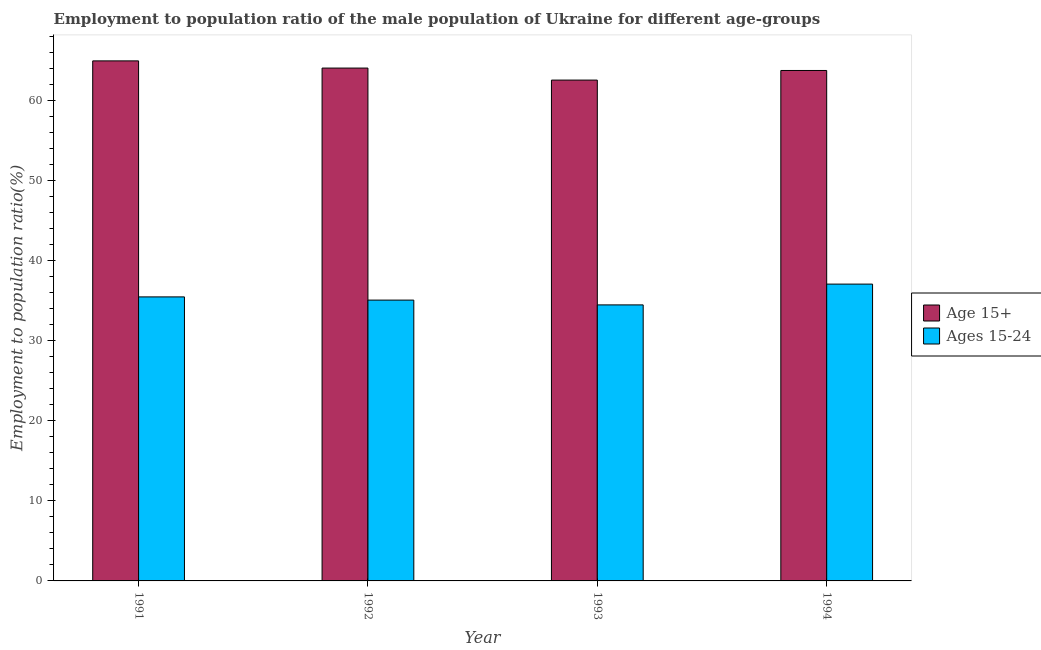How many groups of bars are there?
Your answer should be compact. 4. Are the number of bars on each tick of the X-axis equal?
Give a very brief answer. Yes. How many bars are there on the 4th tick from the right?
Provide a succinct answer. 2. In how many cases, is the number of bars for a given year not equal to the number of legend labels?
Give a very brief answer. 0. What is the employment to population ratio(age 15-24) in 1993?
Make the answer very short. 34.5. Across all years, what is the maximum employment to population ratio(age 15-24)?
Keep it short and to the point. 37.1. Across all years, what is the minimum employment to population ratio(age 15-24)?
Your answer should be very brief. 34.5. In which year was the employment to population ratio(age 15+) minimum?
Offer a very short reply. 1993. What is the total employment to population ratio(age 15-24) in the graph?
Offer a terse response. 142.2. What is the difference between the employment to population ratio(age 15+) in 1993 and that in 1994?
Offer a very short reply. -1.2. What is the difference between the employment to population ratio(age 15-24) in 1991 and the employment to population ratio(age 15+) in 1993?
Give a very brief answer. 1. What is the average employment to population ratio(age 15-24) per year?
Offer a very short reply. 35.55. What is the ratio of the employment to population ratio(age 15-24) in 1991 to that in 1994?
Make the answer very short. 0.96. Is the employment to population ratio(age 15+) in 1992 less than that in 1994?
Provide a short and direct response. No. Is the difference between the employment to population ratio(age 15+) in 1991 and 1993 greater than the difference between the employment to population ratio(age 15-24) in 1991 and 1993?
Offer a terse response. No. What is the difference between the highest and the second highest employment to population ratio(age 15-24)?
Make the answer very short. 1.6. What is the difference between the highest and the lowest employment to population ratio(age 15-24)?
Ensure brevity in your answer.  2.6. What does the 2nd bar from the left in 1991 represents?
Provide a succinct answer. Ages 15-24. What does the 2nd bar from the right in 1991 represents?
Keep it short and to the point. Age 15+. What is the difference between two consecutive major ticks on the Y-axis?
Your answer should be very brief. 10. Are the values on the major ticks of Y-axis written in scientific E-notation?
Make the answer very short. No. Does the graph contain grids?
Offer a very short reply. No. Where does the legend appear in the graph?
Provide a short and direct response. Center right. How many legend labels are there?
Provide a short and direct response. 2. What is the title of the graph?
Your response must be concise. Employment to population ratio of the male population of Ukraine for different age-groups. Does "Study and work" appear as one of the legend labels in the graph?
Provide a succinct answer. No. What is the label or title of the Y-axis?
Offer a terse response. Employment to population ratio(%). What is the Employment to population ratio(%) in Ages 15-24 in 1991?
Provide a succinct answer. 35.5. What is the Employment to population ratio(%) of Age 15+ in 1992?
Your answer should be very brief. 64.1. What is the Employment to population ratio(%) in Ages 15-24 in 1992?
Your answer should be very brief. 35.1. What is the Employment to population ratio(%) of Age 15+ in 1993?
Your answer should be very brief. 62.6. What is the Employment to population ratio(%) in Ages 15-24 in 1993?
Provide a short and direct response. 34.5. What is the Employment to population ratio(%) in Age 15+ in 1994?
Provide a short and direct response. 63.8. What is the Employment to population ratio(%) in Ages 15-24 in 1994?
Make the answer very short. 37.1. Across all years, what is the maximum Employment to population ratio(%) of Age 15+?
Your answer should be compact. 65. Across all years, what is the maximum Employment to population ratio(%) in Ages 15-24?
Give a very brief answer. 37.1. Across all years, what is the minimum Employment to population ratio(%) in Age 15+?
Give a very brief answer. 62.6. Across all years, what is the minimum Employment to population ratio(%) of Ages 15-24?
Keep it short and to the point. 34.5. What is the total Employment to population ratio(%) of Age 15+ in the graph?
Give a very brief answer. 255.5. What is the total Employment to population ratio(%) of Ages 15-24 in the graph?
Make the answer very short. 142.2. What is the difference between the Employment to population ratio(%) in Ages 15-24 in 1991 and that in 1992?
Provide a succinct answer. 0.4. What is the difference between the Employment to population ratio(%) of Age 15+ in 1991 and that in 1994?
Your answer should be compact. 1.2. What is the difference between the Employment to population ratio(%) of Age 15+ in 1992 and that in 1993?
Make the answer very short. 1.5. What is the difference between the Employment to population ratio(%) of Ages 15-24 in 1992 and that in 1993?
Offer a very short reply. 0.6. What is the difference between the Employment to population ratio(%) of Age 15+ in 1992 and that in 1994?
Offer a terse response. 0.3. What is the difference between the Employment to population ratio(%) in Age 15+ in 1993 and that in 1994?
Offer a terse response. -1.2. What is the difference between the Employment to population ratio(%) in Ages 15-24 in 1993 and that in 1994?
Offer a terse response. -2.6. What is the difference between the Employment to population ratio(%) of Age 15+ in 1991 and the Employment to population ratio(%) of Ages 15-24 in 1992?
Your answer should be very brief. 29.9. What is the difference between the Employment to population ratio(%) in Age 15+ in 1991 and the Employment to population ratio(%) in Ages 15-24 in 1993?
Give a very brief answer. 30.5. What is the difference between the Employment to population ratio(%) of Age 15+ in 1991 and the Employment to population ratio(%) of Ages 15-24 in 1994?
Offer a terse response. 27.9. What is the difference between the Employment to population ratio(%) in Age 15+ in 1992 and the Employment to population ratio(%) in Ages 15-24 in 1993?
Offer a terse response. 29.6. What is the difference between the Employment to population ratio(%) of Age 15+ in 1993 and the Employment to population ratio(%) of Ages 15-24 in 1994?
Ensure brevity in your answer.  25.5. What is the average Employment to population ratio(%) in Age 15+ per year?
Your response must be concise. 63.88. What is the average Employment to population ratio(%) in Ages 15-24 per year?
Make the answer very short. 35.55. In the year 1991, what is the difference between the Employment to population ratio(%) of Age 15+ and Employment to population ratio(%) of Ages 15-24?
Offer a very short reply. 29.5. In the year 1992, what is the difference between the Employment to population ratio(%) of Age 15+ and Employment to population ratio(%) of Ages 15-24?
Your answer should be compact. 29. In the year 1993, what is the difference between the Employment to population ratio(%) in Age 15+ and Employment to population ratio(%) in Ages 15-24?
Give a very brief answer. 28.1. In the year 1994, what is the difference between the Employment to population ratio(%) of Age 15+ and Employment to population ratio(%) of Ages 15-24?
Offer a very short reply. 26.7. What is the ratio of the Employment to population ratio(%) of Age 15+ in 1991 to that in 1992?
Provide a succinct answer. 1.01. What is the ratio of the Employment to population ratio(%) of Ages 15-24 in 1991 to that in 1992?
Your answer should be very brief. 1.01. What is the ratio of the Employment to population ratio(%) in Age 15+ in 1991 to that in 1993?
Offer a very short reply. 1.04. What is the ratio of the Employment to population ratio(%) of Age 15+ in 1991 to that in 1994?
Keep it short and to the point. 1.02. What is the ratio of the Employment to population ratio(%) in Ages 15-24 in 1991 to that in 1994?
Provide a succinct answer. 0.96. What is the ratio of the Employment to population ratio(%) of Age 15+ in 1992 to that in 1993?
Your response must be concise. 1.02. What is the ratio of the Employment to population ratio(%) in Ages 15-24 in 1992 to that in 1993?
Offer a very short reply. 1.02. What is the ratio of the Employment to population ratio(%) in Age 15+ in 1992 to that in 1994?
Keep it short and to the point. 1. What is the ratio of the Employment to population ratio(%) in Ages 15-24 in 1992 to that in 1994?
Provide a succinct answer. 0.95. What is the ratio of the Employment to population ratio(%) of Age 15+ in 1993 to that in 1994?
Offer a terse response. 0.98. What is the ratio of the Employment to population ratio(%) of Ages 15-24 in 1993 to that in 1994?
Provide a short and direct response. 0.93. What is the difference between the highest and the second highest Employment to population ratio(%) of Age 15+?
Ensure brevity in your answer.  0.9. What is the difference between the highest and the second highest Employment to population ratio(%) of Ages 15-24?
Provide a short and direct response. 1.6. What is the difference between the highest and the lowest Employment to population ratio(%) of Ages 15-24?
Provide a succinct answer. 2.6. 